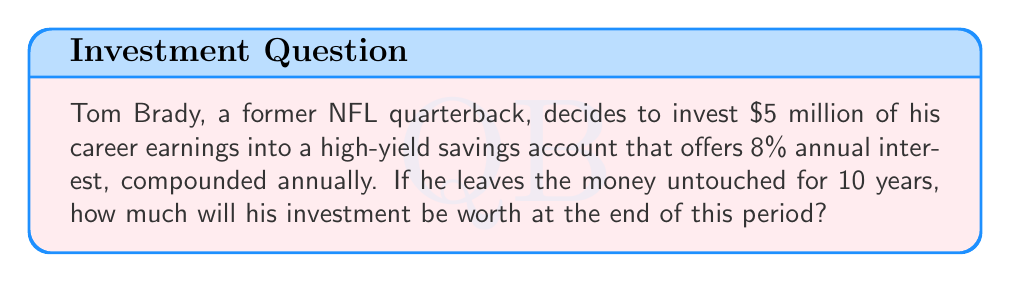Can you answer this question? To solve this problem, we'll use the compound interest formula:

$$ A = P(1 + r)^n $$

Where:
$A$ = Final amount
$P$ = Principal (initial investment)
$r$ = Annual interest rate (as a decimal)
$n$ = Number of years

Given:
$P = \$5,000,000$
$r = 8\% = 0.08$
$n = 10$ years

Let's substitute these values into the formula:

$$ A = 5,000,000(1 + 0.08)^{10} $$

Now, let's calculate step by step:

1) First, calculate $(1 + 0.08)$:
   $1 + 0.08 = 1.08$

2) Now, raise 1.08 to the power of 10:
   $1.08^{10} \approx 2.1589$

3) Finally, multiply this by the principal:
   $5,000,000 \times 2.1589 \approx 10,794,500$

Therefore, after 10 years, Tom Brady's investment will be worth approximately $10,794,500.
Answer: $10,794,500 